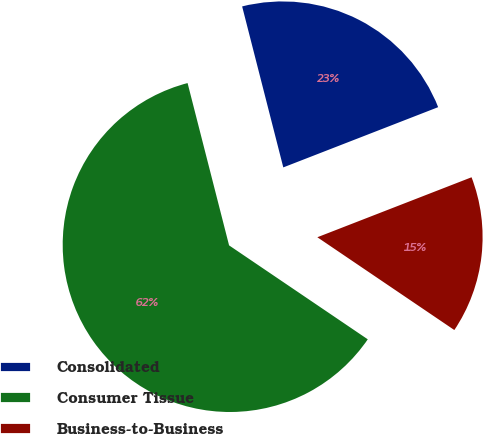Convert chart. <chart><loc_0><loc_0><loc_500><loc_500><pie_chart><fcel>Consolidated<fcel>Consumer Tissue<fcel>Business-to-Business<nl><fcel>23.08%<fcel>61.54%<fcel>15.38%<nl></chart> 